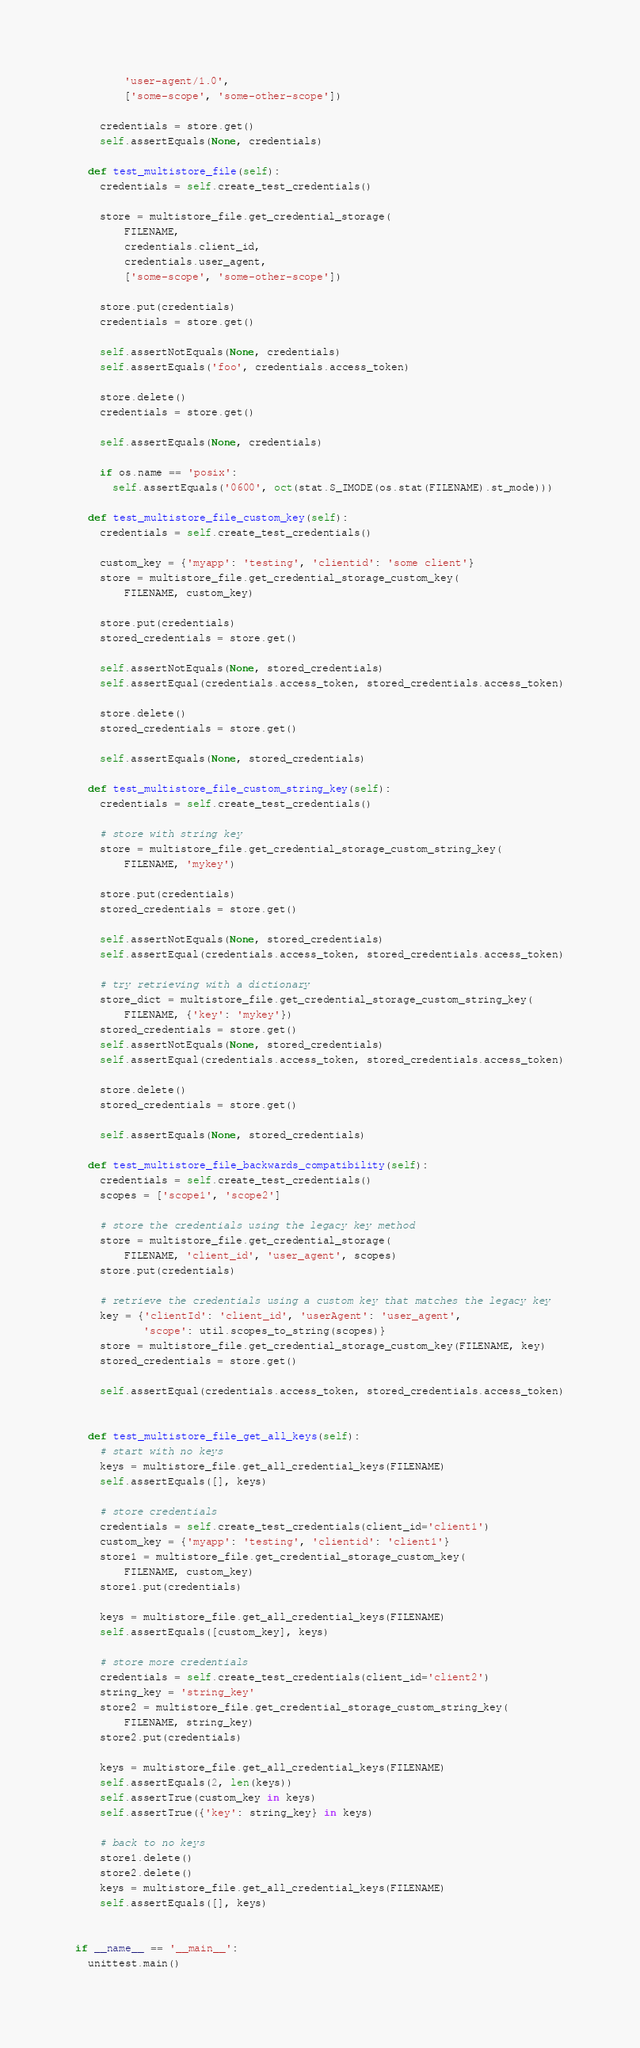Convert code to text. <code><loc_0><loc_0><loc_500><loc_500><_Python_>        'user-agent/1.0',
        ['some-scope', 'some-other-scope'])

    credentials = store.get()
    self.assertEquals(None, credentials)

  def test_multistore_file(self):
    credentials = self.create_test_credentials()

    store = multistore_file.get_credential_storage(
        FILENAME,
        credentials.client_id,
        credentials.user_agent,
        ['some-scope', 'some-other-scope'])

    store.put(credentials)
    credentials = store.get()

    self.assertNotEquals(None, credentials)
    self.assertEquals('foo', credentials.access_token)

    store.delete()
    credentials = store.get()

    self.assertEquals(None, credentials)

    if os.name == 'posix':
      self.assertEquals('0600', oct(stat.S_IMODE(os.stat(FILENAME).st_mode)))

  def test_multistore_file_custom_key(self):
    credentials = self.create_test_credentials()

    custom_key = {'myapp': 'testing', 'clientid': 'some client'}
    store = multistore_file.get_credential_storage_custom_key(
        FILENAME, custom_key)

    store.put(credentials)
    stored_credentials = store.get()

    self.assertNotEquals(None, stored_credentials)
    self.assertEqual(credentials.access_token, stored_credentials.access_token)

    store.delete()
    stored_credentials = store.get()

    self.assertEquals(None, stored_credentials)

  def test_multistore_file_custom_string_key(self):
    credentials = self.create_test_credentials()

    # store with string key
    store = multistore_file.get_credential_storage_custom_string_key(
        FILENAME, 'mykey')

    store.put(credentials)
    stored_credentials = store.get()

    self.assertNotEquals(None, stored_credentials)
    self.assertEqual(credentials.access_token, stored_credentials.access_token)

    # try retrieving with a dictionary
    store_dict = multistore_file.get_credential_storage_custom_string_key(
        FILENAME, {'key': 'mykey'})
    stored_credentials = store.get()
    self.assertNotEquals(None, stored_credentials)
    self.assertEqual(credentials.access_token, stored_credentials.access_token)

    store.delete()
    stored_credentials = store.get()

    self.assertEquals(None, stored_credentials)

  def test_multistore_file_backwards_compatibility(self):
    credentials = self.create_test_credentials()
    scopes = ['scope1', 'scope2']

    # store the credentials using the legacy key method
    store = multistore_file.get_credential_storage(
        FILENAME, 'client_id', 'user_agent', scopes)
    store.put(credentials)

    # retrieve the credentials using a custom key that matches the legacy key
    key = {'clientId': 'client_id', 'userAgent': 'user_agent',
           'scope': util.scopes_to_string(scopes)}
    store = multistore_file.get_credential_storage_custom_key(FILENAME, key)
    stored_credentials = store.get()

    self.assertEqual(credentials.access_token, stored_credentials.access_token)


  def test_multistore_file_get_all_keys(self):
    # start with no keys
    keys = multistore_file.get_all_credential_keys(FILENAME)
    self.assertEquals([], keys)

    # store credentials
    credentials = self.create_test_credentials(client_id='client1')
    custom_key = {'myapp': 'testing', 'clientid': 'client1'}
    store1 = multistore_file.get_credential_storage_custom_key(
        FILENAME, custom_key)
    store1.put(credentials)

    keys = multistore_file.get_all_credential_keys(FILENAME)
    self.assertEquals([custom_key], keys)

    # store more credentials
    credentials = self.create_test_credentials(client_id='client2')
    string_key = 'string_key'
    store2 = multistore_file.get_credential_storage_custom_string_key(
        FILENAME, string_key)
    store2.put(credentials)

    keys = multistore_file.get_all_credential_keys(FILENAME)
    self.assertEquals(2, len(keys))
    self.assertTrue(custom_key in keys)
    self.assertTrue({'key': string_key} in keys)

    # back to no keys
    store1.delete()
    store2.delete()
    keys = multistore_file.get_all_credential_keys(FILENAME)
    self.assertEquals([], keys)


if __name__ == '__main__':
  unittest.main()
</code> 